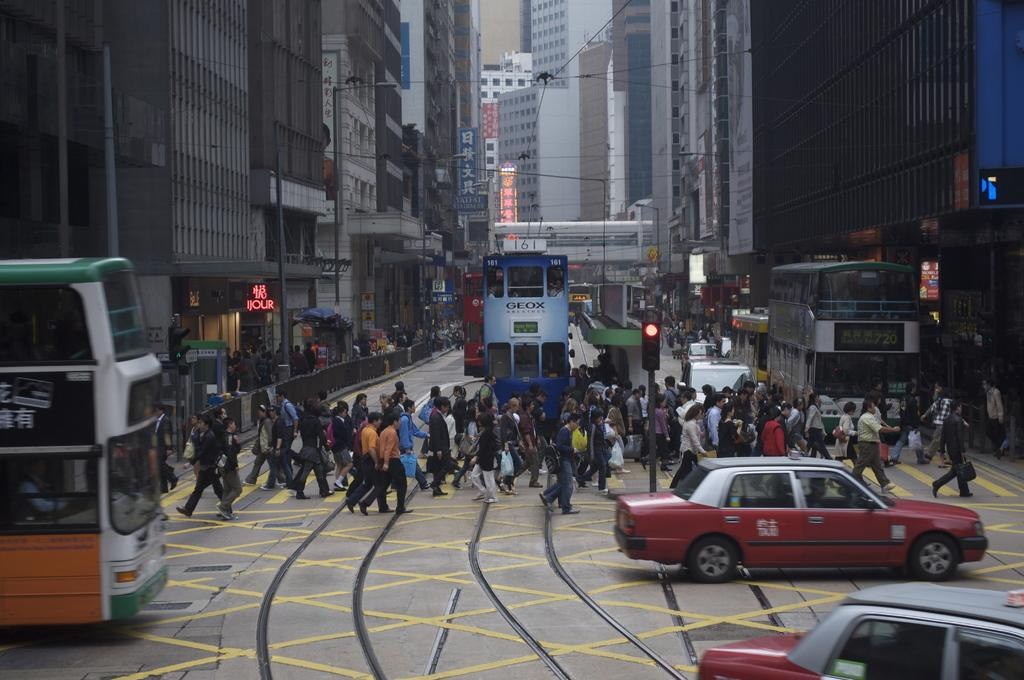<image>
Relay a brief, clear account of the picture shown. Public transportation that has a sign of GEOX on it heads down a busy street. 